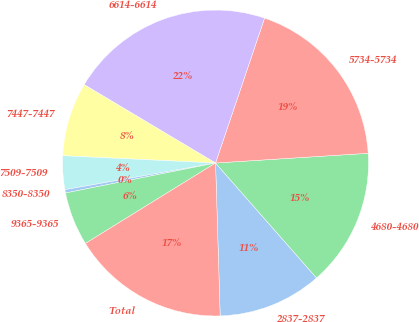Convert chart. <chart><loc_0><loc_0><loc_500><loc_500><pie_chart><fcel>2837-2837<fcel>4680-4680<fcel>5734-5734<fcel>6614-6614<fcel>7447-7447<fcel>7509-7509<fcel>8350-8350<fcel>9365-9365<fcel>Total<nl><fcel>10.99%<fcel>14.54%<fcel>18.79%<fcel>21.63%<fcel>7.8%<fcel>3.55%<fcel>0.35%<fcel>5.67%<fcel>16.67%<nl></chart> 